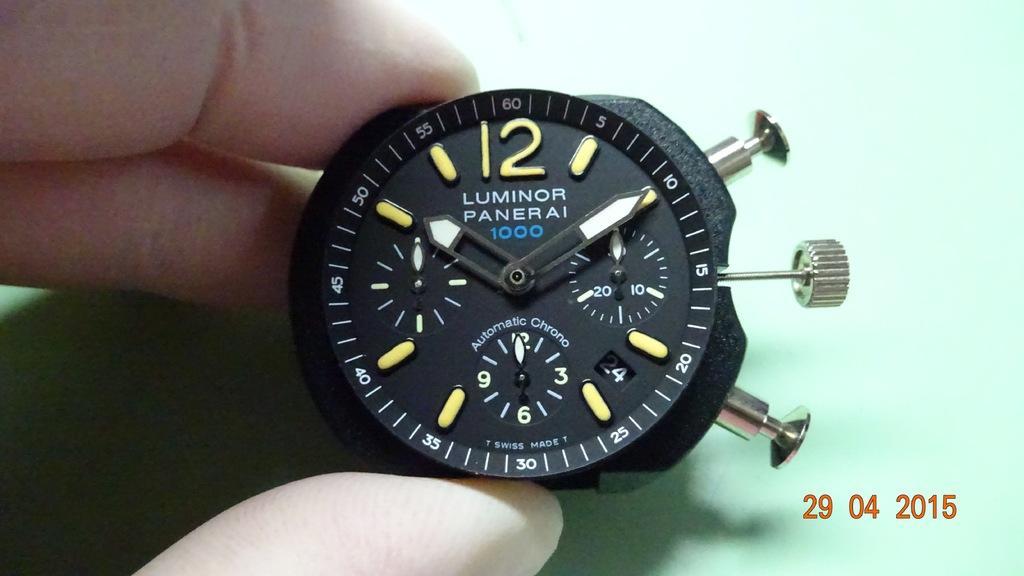Can you describe this image briefly? In this picture I can see there is a person holding a watch and there is a dial, there are number markings and it has a minutes and hour hand and there is something written on the dial and it has few buttons on to right side and there is a green color backdrop. 